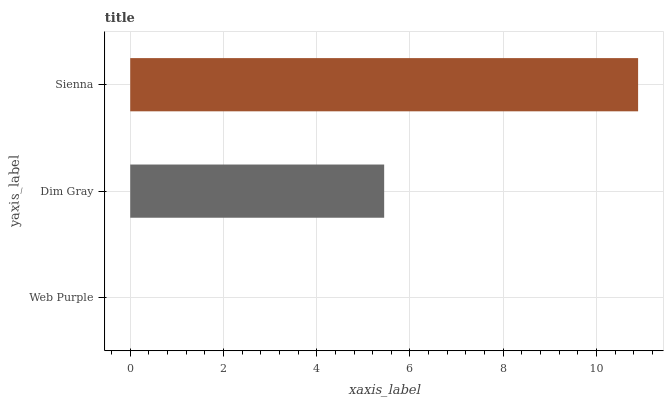Is Web Purple the minimum?
Answer yes or no. Yes. Is Sienna the maximum?
Answer yes or no. Yes. Is Dim Gray the minimum?
Answer yes or no. No. Is Dim Gray the maximum?
Answer yes or no. No. Is Dim Gray greater than Web Purple?
Answer yes or no. Yes. Is Web Purple less than Dim Gray?
Answer yes or no. Yes. Is Web Purple greater than Dim Gray?
Answer yes or no. No. Is Dim Gray less than Web Purple?
Answer yes or no. No. Is Dim Gray the high median?
Answer yes or no. Yes. Is Dim Gray the low median?
Answer yes or no. Yes. Is Sienna the high median?
Answer yes or no. No. Is Web Purple the low median?
Answer yes or no. No. 